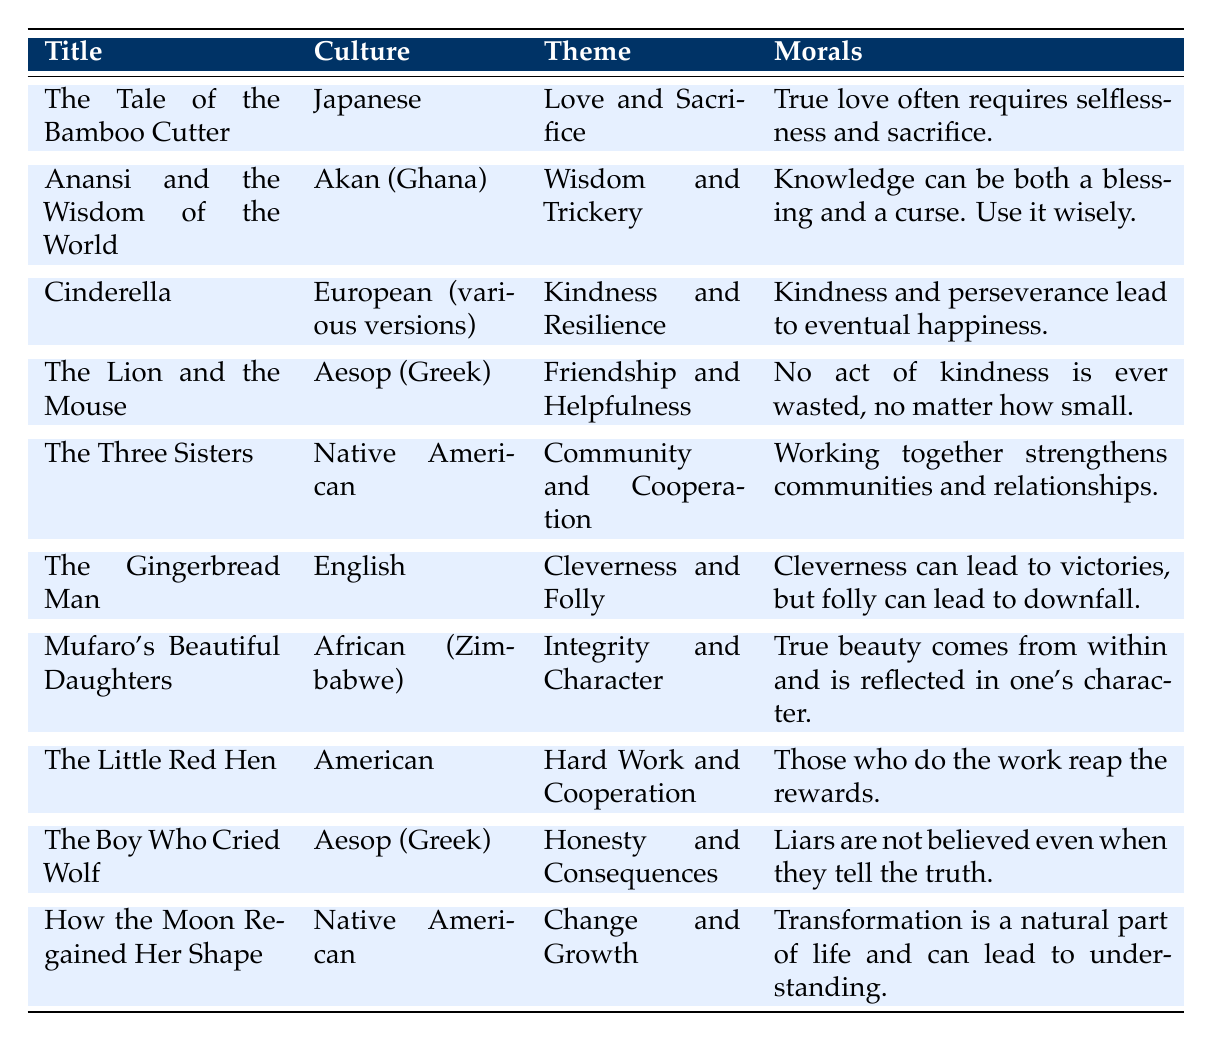What is the theme of "Cinderella"? The table lists "Cinderella" under the theme of "Kindness and Resilience."
Answer: Kindness and Resilience Which culture does "The Lion and the Mouse" belong to? According to the table, "The Lion and the Mouse" is associated with Aesop, which is Greek culture.
Answer: Greek What moral is associated with "The Boy Who Cried Wolf"? The table indicates that the moral of "The Boy Who Cried Wolf" is that liars are not believed even when they tell the truth.
Answer: Liars are not believed even when they tell the truth How many stories emphasize themes related to community or cooperation? In the table, "The Three Sisters" and "The Little Red Hen" both emphasize community or cooperation, therefore there are 2 stories.
Answer: 2 Is "Mufaro's Beautiful Daughters" about integrity? The table shows that "Mufaro's Beautiful Daughters" has the theme of integrity and character.
Answer: Yes What can be concluded about stories from Native American culture based on themes? The table lists two stories from Native American culture: "The Three Sisters," which focuses on community and cooperation, and "How the Moon Regained Her Shape," which involves change and growth, indicating a variety of themes.
Answer: Variety of themes Which story has the moral about the consequences of dishonesty? The table specifies that "The Boy Who Cried Wolf" has the moral concerning dishonesty and its consequences.
Answer: The Boy Who Cried Wolf Are there more stories focused on individual traits like cleverness or community traits? The table shows 3 stories with individual traits ("The Gingerbread Man," "The Lion and the Mouse," and "Anansi and the Wisdom of the World") and 2 with community traits ("The Three Sisters" and "The Little Red Hen"), so individual traits are more.
Answer: Individual traits are more What is the common moral theme shared between "The Lion and the Mouse" and "The Little Red Hen"? The table suggests the common theme is helpfulness, as both stories involve acts of kindness and cooperation leading to positive outcomes.
Answer: Helpfulness Which story teaches that true beauty comes from within? The table indicates that "Mufaro's Beautiful Daughters" teaches that true beauty comes from within.
Answer: Mufaro's Beautiful Daughters 